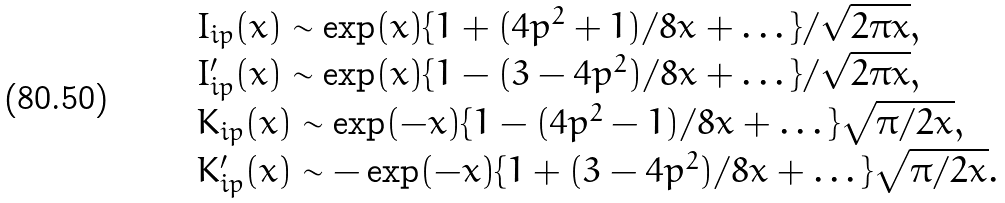<formula> <loc_0><loc_0><loc_500><loc_500>\begin{array} { l } I _ { i p } ( x ) \sim \exp ( x ) \{ 1 + ( 4 p ^ { 2 } + 1 ) / 8 x + \dots \} / \sqrt { 2 \pi x } , \\ I ^ { \prime } _ { i p } ( x ) \sim \exp ( x ) \{ 1 - ( 3 - 4 p ^ { 2 } ) / 8 x + \dots \} / \sqrt { 2 \pi x } , \\ K _ { i p } ( x ) \sim \exp ( - x ) \{ 1 - ( 4 p ^ { 2 } - 1 ) / 8 x + \dots \} \sqrt { \pi / 2 x } , \\ K ^ { \prime } _ { i p } ( x ) \sim - \exp ( - x ) \{ 1 + ( 3 - 4 p ^ { 2 } ) / 8 x + \dots \} \sqrt { \pi / 2 x } . \end{array}</formula> 